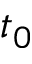<formula> <loc_0><loc_0><loc_500><loc_500>t _ { 0 }</formula> 